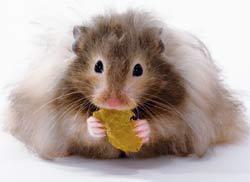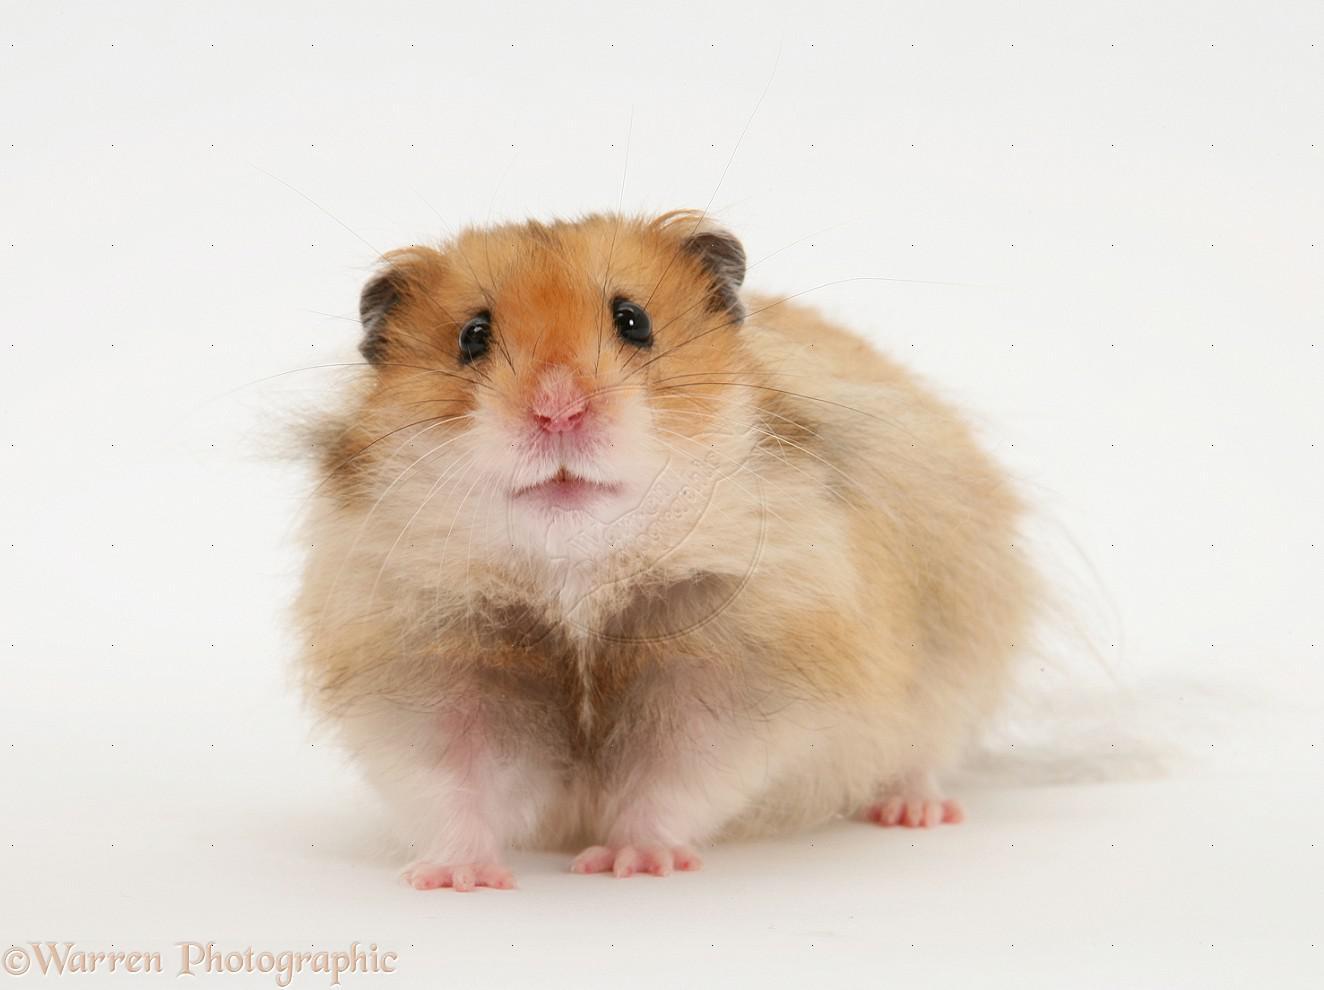The first image is the image on the left, the second image is the image on the right. Evaluate the accuracy of this statement regarding the images: "A light orange hamster is holding a broccoli floret to its mouth with both front paws.". Is it true? Answer yes or no. No. The first image is the image on the left, the second image is the image on the right. Given the left and right images, does the statement "There is a hamster eating a piece of broccoli." hold true? Answer yes or no. No. 